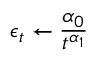<formula> <loc_0><loc_0><loc_500><loc_500>\epsilon _ { t } \leftarrow \frac { \alpha _ { 0 } } { t ^ { \alpha _ { 1 } } }</formula> 